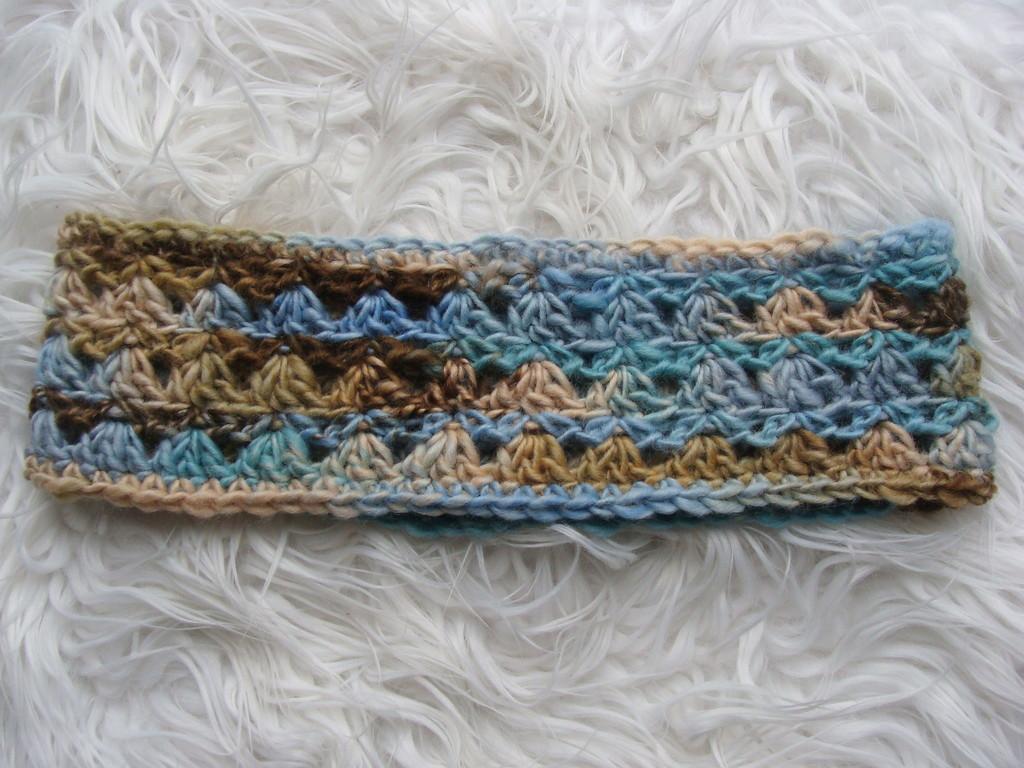In one or two sentences, can you explain what this image depicts? In this image there is a knitted cloth on the white woolen cloth. 